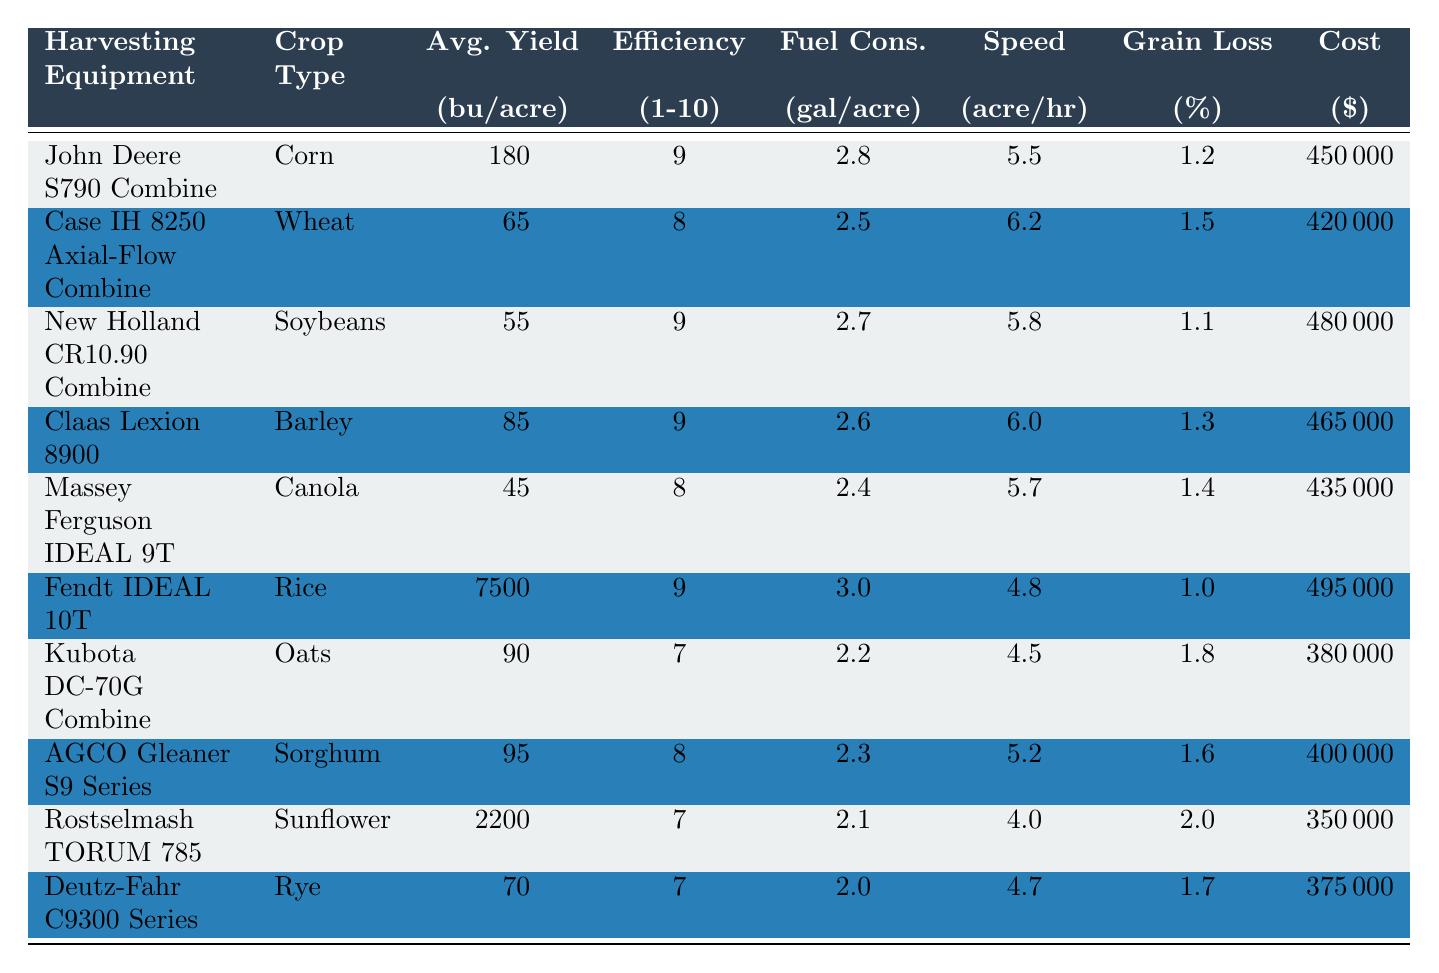What is the average yield of the Fendt IDEAL 10T for rice? The average yield for the Fendt IDEAL 10T with rice is listed directly in the table as 7500 bushels per acre.
Answer: 7500 What is the efficiency rating of the John Deere S790 Combine? The efficiency rating for the John Deere S790 Combine can be found in the table under the corresponding column, which shows a rating of 9.
Answer: 9 Which harvesting equipment has the lowest initial cost? The table lists the initial costs for all harvesting equipment. The lowest initial cost is for the Rostselmash TORUM 785 at $350,000.
Answer: $350,000 Is the fuel consumption of the Case IH 8250 Axial-Flow Combine lower than that of the Kubota DC-70G Combine? The fuel consumption for Case IH 8250 is 2.5 gallons per acre, while for Kubota DC-70G, it is 2.2 gallons per acre. Since 2.5 is greater than 2.2, the statement is false.
Answer: No What is the difference in average yield between corn and soybeans? From the table, the average yield for corn (John Deere S790 Combine) is 180 bushels per acre, and for soybeans (New Holland CR10.90 Combine) is 55 bushels per acre. The difference is 180 - 55 = 125 bushels per acre.
Answer: 125 Which crop type has the highest grain loss percentage, and what is that percentage? Looking through the table, the grain loss for each crop type shows that the Fendt IDEAL 10T for rice has the lowest grain loss at 1.0%, while the Kubota DC-70G Combine for oats has the highest at 1.8%. The highest is 1.8% for oats.
Answer: 1.8% What is the average fuel consumption of all the harvesting equipment listed? To find the average fuel consumption, add all the fuel consumption values: (2.8 + 2.5 + 2.7 + 2.6 + 2.4 + 3.0 + 2.2 + 2.3 + 2.1 + 2.0) = 26.6 gallons. Then divide by 10 (the number of equipment types) to get the average: 26.6 / 10 = 2.66 gallons per acre.
Answer: 2.66 True or false: The Claas Lexion 8900 has an average yield of more than 70 bushels per acre. The table indicates the average yield for Claas Lexion 8900 is 85 bushels per acre, which is more than 70. Therefore, this statement is true.
Answer: True If you were to rank the harvesting equipment by average yield from highest to lowest, what would be the yield of the second-ranked equipment? The highest yield is the Fendt IDEAL 10T with 7500 bushels per acre, followed by Rostselmash TORUM 785 with 2200 bushels per acre when listed in order. Thus, the second-ranked yield is 2200 bushels per acre.
Answer: 2200 What is the total initial cost of all the harvesters? To find the total initial cost, sum all the costs: 450000 + 420000 + 480000 + 465000 + 435000 + 495000 + 380000 + 400000 + 350000 + 375000 = 4500000.
Answer: $4,500,000 